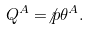Convert formula to latex. <formula><loc_0><loc_0><loc_500><loc_500>Q ^ { A } = \not { p } \theta ^ { A } .</formula> 